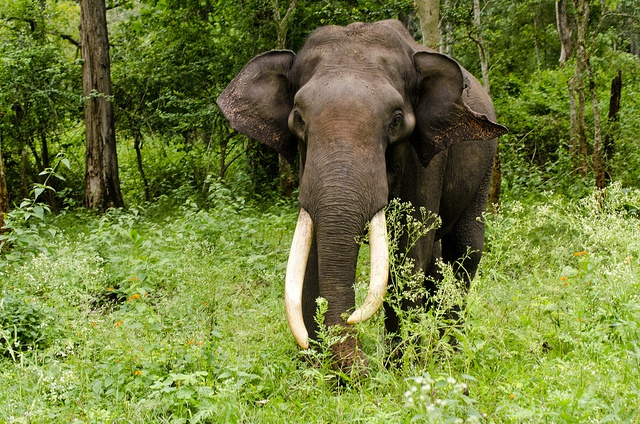Describe the objects in this image and their specific colors. I can see a elephant in olive, black, and gray tones in this image. 